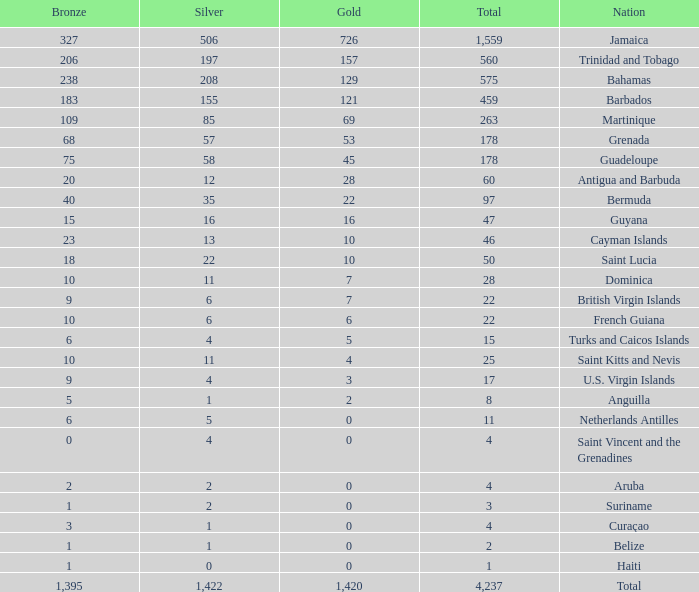Help me parse the entirety of this table. {'header': ['Bronze', 'Silver', 'Gold', 'Total', 'Nation'], 'rows': [['327', '506', '726', '1,559', 'Jamaica'], ['206', '197', '157', '560', 'Trinidad and Tobago'], ['238', '208', '129', '575', 'Bahamas'], ['183', '155', '121', '459', 'Barbados'], ['109', '85', '69', '263', 'Martinique'], ['68', '57', '53', '178', 'Grenada'], ['75', '58', '45', '178', 'Guadeloupe'], ['20', '12', '28', '60', 'Antigua and Barbuda'], ['40', '35', '22', '97', 'Bermuda'], ['15', '16', '16', '47', 'Guyana'], ['23', '13', '10', '46', 'Cayman Islands'], ['18', '22', '10', '50', 'Saint Lucia'], ['10', '11', '7', '28', 'Dominica'], ['9', '6', '7', '22', 'British Virgin Islands'], ['10', '6', '6', '22', 'French Guiana'], ['6', '4', '5', '15', 'Turks and Caicos Islands'], ['10', '11', '4', '25', 'Saint Kitts and Nevis'], ['9', '4', '3', '17', 'U.S. Virgin Islands'], ['5', '1', '2', '8', 'Anguilla'], ['6', '5', '0', '11', 'Netherlands Antilles'], ['0', '4', '0', '4', 'Saint Vincent and the Grenadines'], ['2', '2', '0', '4', 'Aruba'], ['1', '2', '0', '3', 'Suriname'], ['3', '1', '0', '4', 'Curaçao'], ['1', '1', '0', '2', 'Belize'], ['1', '0', '0', '1', 'Haiti'], ['1,395', '1,422', '1,420', '4,237', 'Total']]} What's the sum of Silver with total smaller than 560, a Bronze larger than 6, and a Gold of 3? 4.0. 